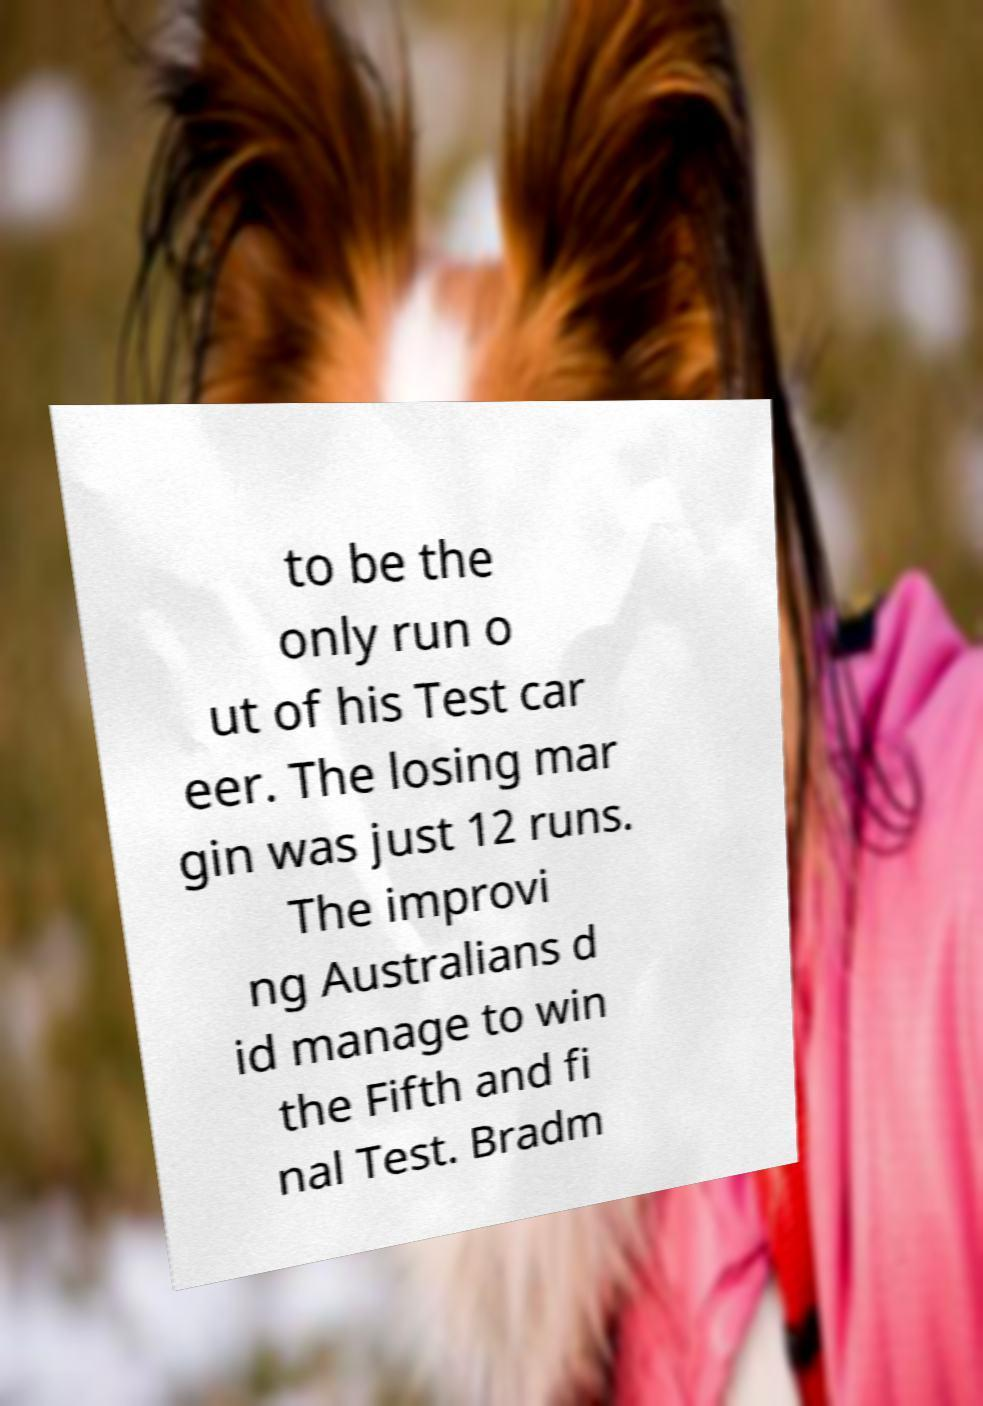Could you extract and type out the text from this image? to be the only run o ut of his Test car eer. The losing mar gin was just 12 runs. The improvi ng Australians d id manage to win the Fifth and fi nal Test. Bradm 